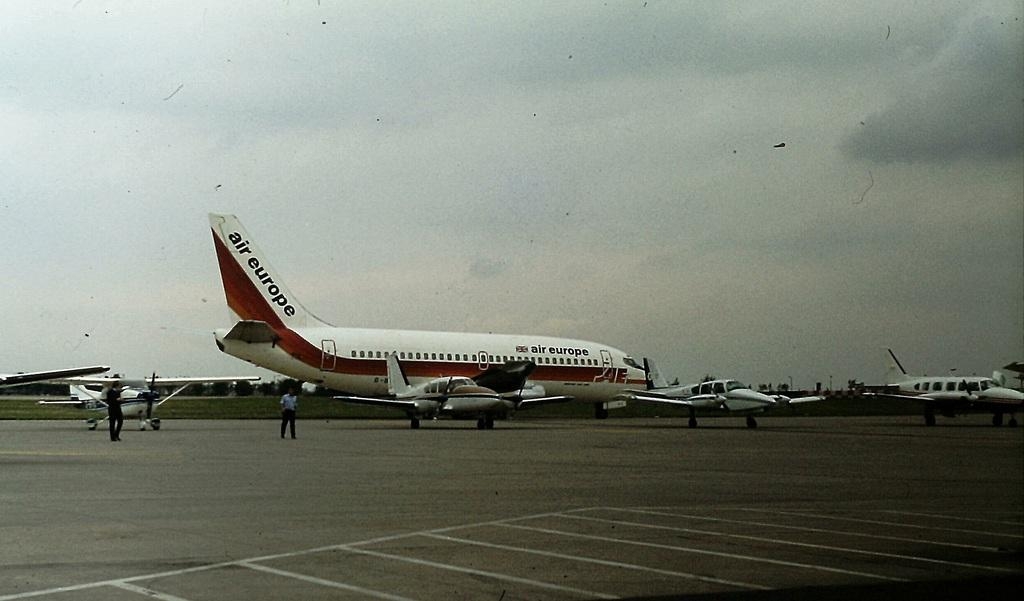<image>
Share a concise interpretation of the image provided. A white Air Europe plane with a red horizontal stripe sitting on the tarmac. 